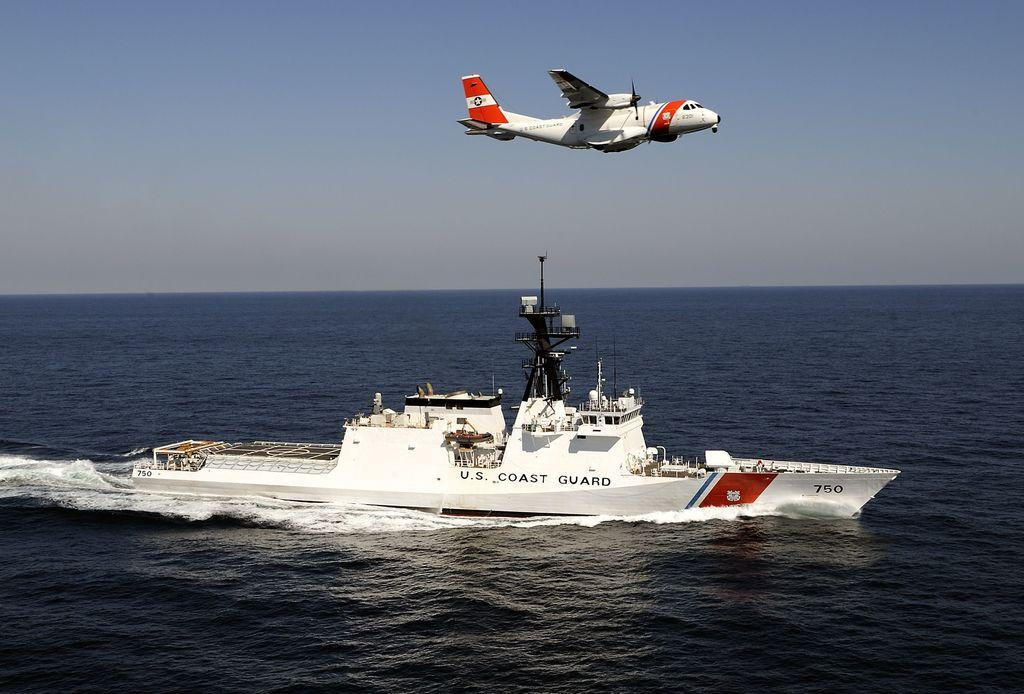What is the main subject of the image? The main subject of the image is a ship sailing on the water. Can you describe another mode of transportation in the image? Yes, there is an aircraft in the air in the image. What part of the natural environment is visible in the image? The sky is visible in the image. How many wrens can be seen flying near the ship in the image? There are no wrens visible in the image. What time of day is depicted in the image? The time of day cannot be determined from the image alone. 